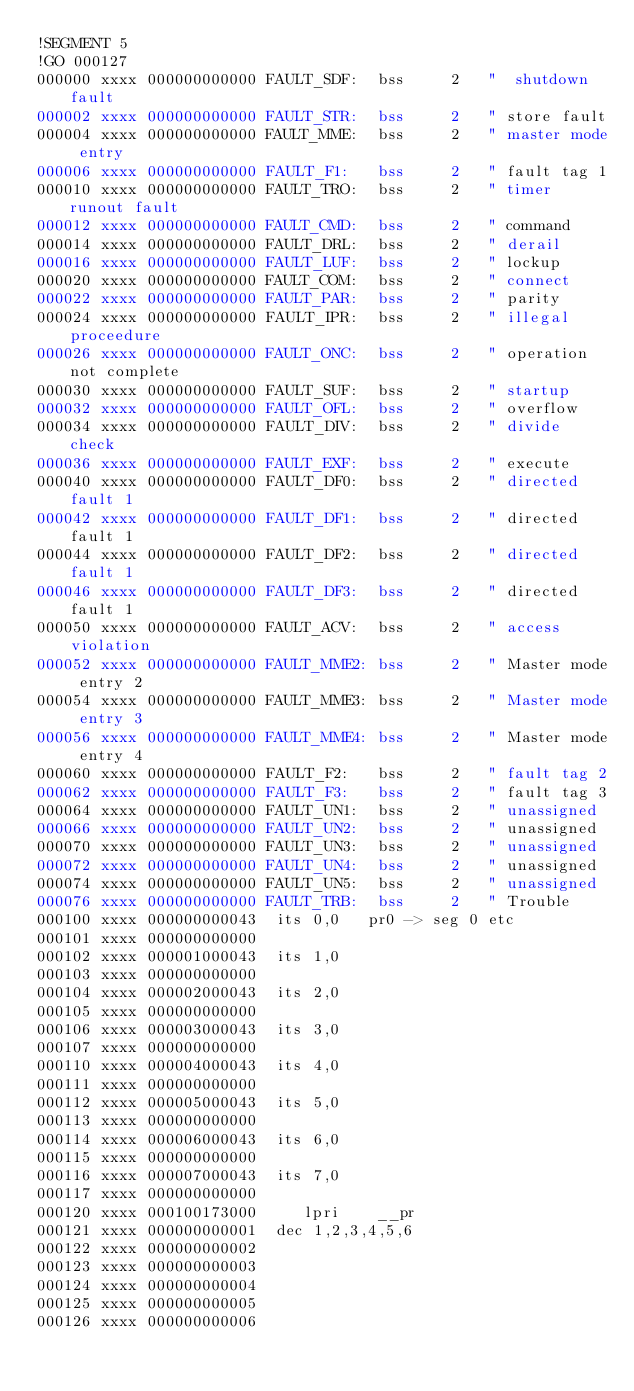Convert code to text. <code><loc_0><loc_0><loc_500><loc_500><_Octave_>!SEGMENT 5
!GO 000127
000000 xxxx 000000000000 FAULT_SDF:  bss     2   "  shutdown fault
000002 xxxx 000000000000 FAULT_STR:  bss     2   " store fault
000004 xxxx 000000000000 FAULT_MME:  bss     2   " master mode entry
000006 xxxx 000000000000 FAULT_F1:   bss     2   " fault tag 1
000010 xxxx 000000000000 FAULT_TRO:  bss     2   " timer runout fault
000012 xxxx 000000000000 FAULT_CMD:  bss     2   " command
000014 xxxx 000000000000 FAULT_DRL:  bss     2   " derail
000016 xxxx 000000000000 FAULT_LUF:  bss     2   " lockup
000020 xxxx 000000000000 FAULT_COM:  bss     2   " connect
000022 xxxx 000000000000 FAULT_PAR:  bss     2   " parity
000024 xxxx 000000000000 FAULT_IPR:  bss     2   " illegal proceedure
000026 xxxx 000000000000 FAULT_ONC:  bss     2   " operation not complete
000030 xxxx 000000000000 FAULT_SUF:  bss     2   " startup
000032 xxxx 000000000000 FAULT_OFL:  bss     2   " overflow
000034 xxxx 000000000000 FAULT_DIV:  bss     2   " divide check
000036 xxxx 000000000000 FAULT_EXF:  bss     2   " execute
000040 xxxx 000000000000 FAULT_DF0:  bss     2   " directed fault 1
000042 xxxx 000000000000 FAULT_DF1:  bss     2   " directed fault 1
000044 xxxx 000000000000 FAULT_DF2:  bss     2   " directed fault 1
000046 xxxx 000000000000 FAULT_DF3:  bss     2   " directed fault 1
000050 xxxx 000000000000 FAULT_ACV:  bss     2   " access violation
000052 xxxx 000000000000 FAULT_MME2: bss     2   " Master mode entry 2
000054 xxxx 000000000000 FAULT_MME3: bss     2   " Master mode entry 3
000056 xxxx 000000000000 FAULT_MME4: bss     2   " Master mode entry 4
000060 xxxx 000000000000 FAULT_F2:   bss     2   " fault tag 2
000062 xxxx 000000000000 FAULT_F3:   bss     2   " fault tag 3
000064 xxxx 000000000000 FAULT_UN1:  bss     2   " unassigned
000066 xxxx 000000000000 FAULT_UN2:  bss     2   " unassigned
000070 xxxx 000000000000 FAULT_UN3:  bss     2   " unassigned
000072 xxxx 000000000000 FAULT_UN4:  bss     2   " unassigned
000074 xxxx 000000000000 FAULT_UN5:  bss     2   " unassigned
000076 xxxx 000000000000 FAULT_TRB:  bss     2   " Trouble
000100 xxxx 000000000043 	its	0,0		pr0 -> seg 0 etc 
000101 xxxx 000000000000
000102 xxxx 000001000043 	its	1,0 
000103 xxxx 000000000000
000104 xxxx 000002000043 	its	2,0 
000105 xxxx 000000000000
000106 xxxx 000003000043 	its	3,0 
000107 xxxx 000000000000
000110 xxxx 000004000043 	its	4,0 
000111 xxxx 000000000000
000112 xxxx 000005000043 	its	5,0 
000113 xxxx 000000000000
000114 xxxx 000006000043 	its	6,0 
000115 xxxx 000000000000
000116 xxxx 000007000043 	its	7,0 
000117 xxxx 000000000000
000120 xxxx 000100173000     lpri    __pr
000121 xxxx 000000000001 	dec	1,2,3,4,5,6
000122 xxxx 000000000002
000123 xxxx 000000000003
000124 xxxx 000000000004
000125 xxxx 000000000005
000126 xxxx 000000000006</code> 